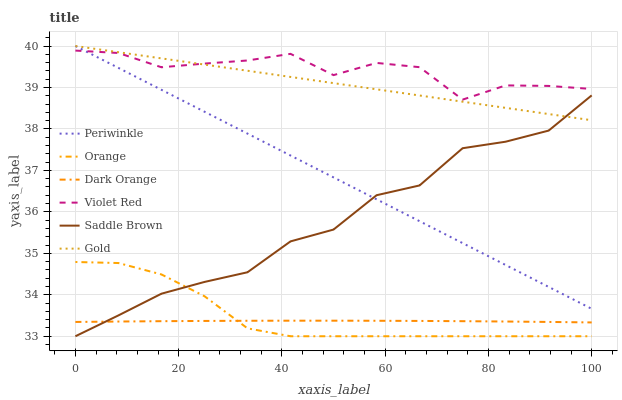Does Dark Orange have the minimum area under the curve?
Answer yes or no. Yes. Does Violet Red have the maximum area under the curve?
Answer yes or no. Yes. Does Gold have the minimum area under the curve?
Answer yes or no. No. Does Gold have the maximum area under the curve?
Answer yes or no. No. Is Periwinkle the smoothest?
Answer yes or no. Yes. Is Violet Red the roughest?
Answer yes or no. Yes. Is Gold the smoothest?
Answer yes or no. No. Is Gold the roughest?
Answer yes or no. No. Does Orange have the lowest value?
Answer yes or no. Yes. Does Gold have the lowest value?
Answer yes or no. No. Does Periwinkle have the highest value?
Answer yes or no. Yes. Does Violet Red have the highest value?
Answer yes or no. No. Is Dark Orange less than Gold?
Answer yes or no. Yes. Is Periwinkle greater than Dark Orange?
Answer yes or no. Yes. Does Periwinkle intersect Gold?
Answer yes or no. Yes. Is Periwinkle less than Gold?
Answer yes or no. No. Is Periwinkle greater than Gold?
Answer yes or no. No. Does Dark Orange intersect Gold?
Answer yes or no. No. 